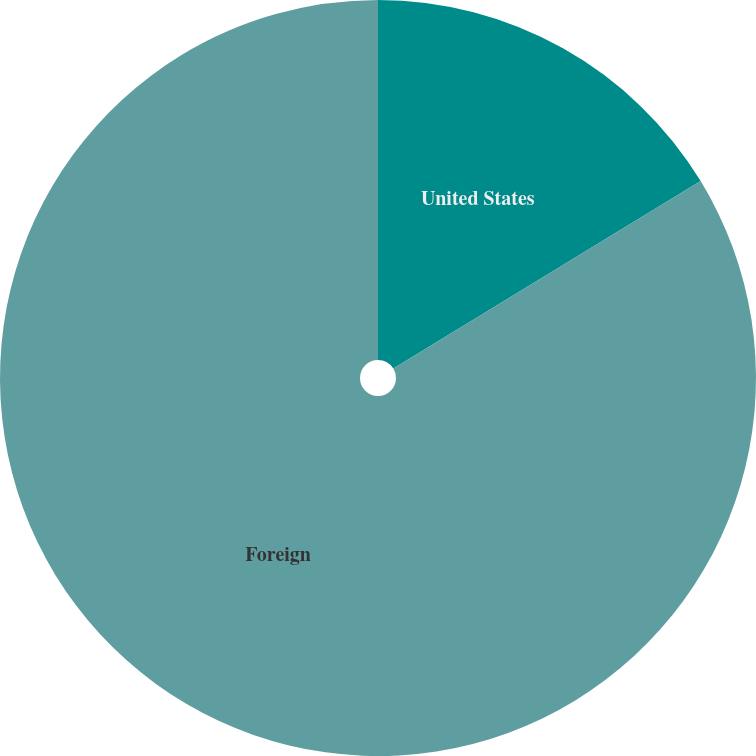Convert chart. <chart><loc_0><loc_0><loc_500><loc_500><pie_chart><fcel>United States<fcel>Foreign<nl><fcel>16.28%<fcel>83.72%<nl></chart> 